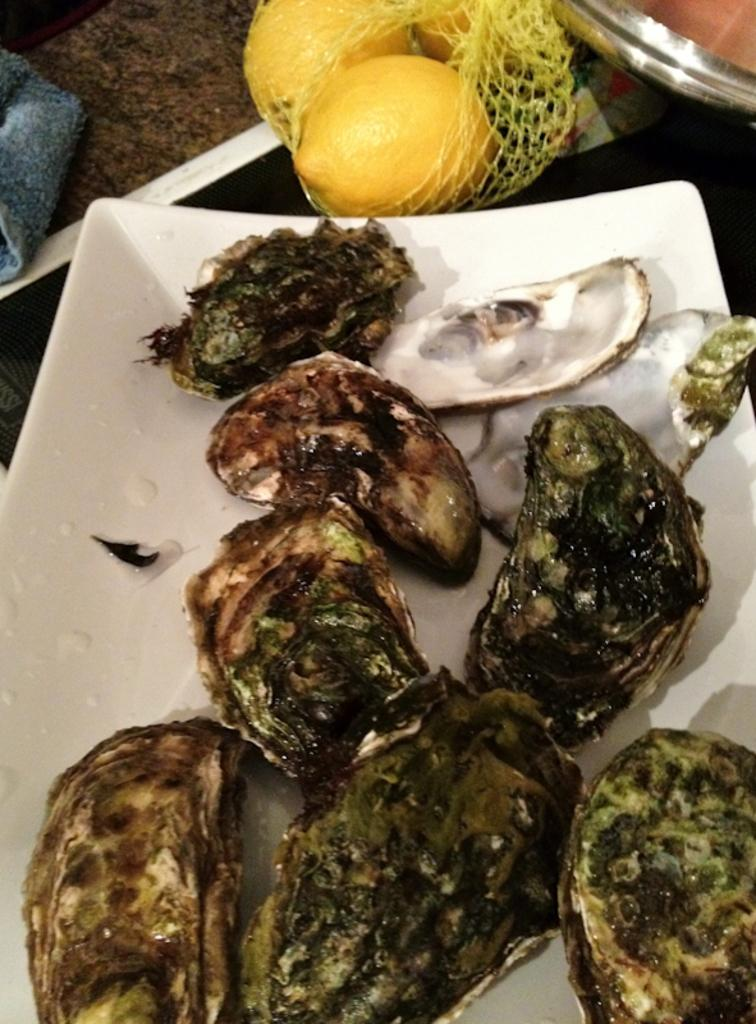What piece of furniture is visible in the image? There is a table in the image. What is placed on the table? There is a plate and food on the table. What type of food can be seen on the table? There are fruits on the table. What might be used for cleaning or wiping in the image? A napkin is present on the table for cleaning or wiping. What historical event is depicted in the image? There is no historical event depicted in the image; it features a table with a plate, food, fruits, and a napkin. Is there any dirt visible on the table in the image? No, there is no dirt visible on the table in the image. 